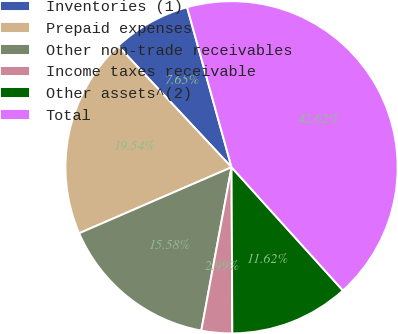Convert chart. <chart><loc_0><loc_0><loc_500><loc_500><pie_chart><fcel>Inventories (1)<fcel>Prepaid expenses<fcel>Other non-trade receivables<fcel>Income taxes receivable<fcel>Other assets^(2)<fcel>Total<nl><fcel>7.65%<fcel>19.54%<fcel>15.58%<fcel>2.99%<fcel>11.62%<fcel>42.62%<nl></chart> 